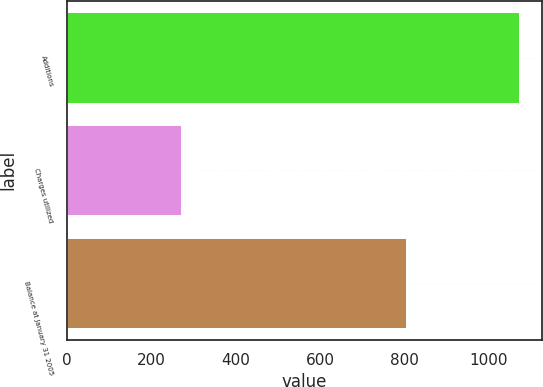Convert chart. <chart><loc_0><loc_0><loc_500><loc_500><bar_chart><fcel>Additions<fcel>Charges utilized<fcel>Balance at January 31 2005<nl><fcel>1073<fcel>270<fcel>803<nl></chart> 